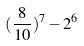Convert formula to latex. <formula><loc_0><loc_0><loc_500><loc_500>( \frac { 8 } { 1 0 } ) ^ { 7 } - 2 ^ { 6 }</formula> 